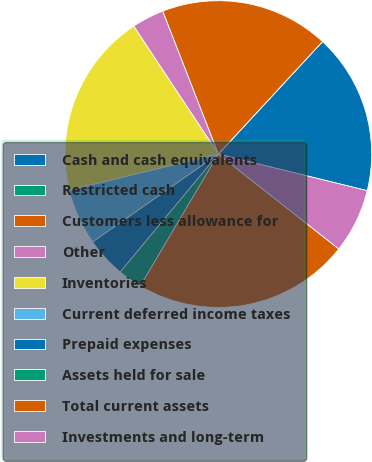Convert chart. <chart><loc_0><loc_0><loc_500><loc_500><pie_chart><fcel>Cash and cash equivalents<fcel>Restricted cash<fcel>Customers less allowance for<fcel>Other<fcel>Inventories<fcel>Current deferred income taxes<fcel>Prepaid expenses<fcel>Assets held for sale<fcel>Total current assets<fcel>Investments and long-term<nl><fcel>16.95%<fcel>0.0%<fcel>17.8%<fcel>3.39%<fcel>19.49%<fcel>5.93%<fcel>4.24%<fcel>2.54%<fcel>22.88%<fcel>6.78%<nl></chart> 